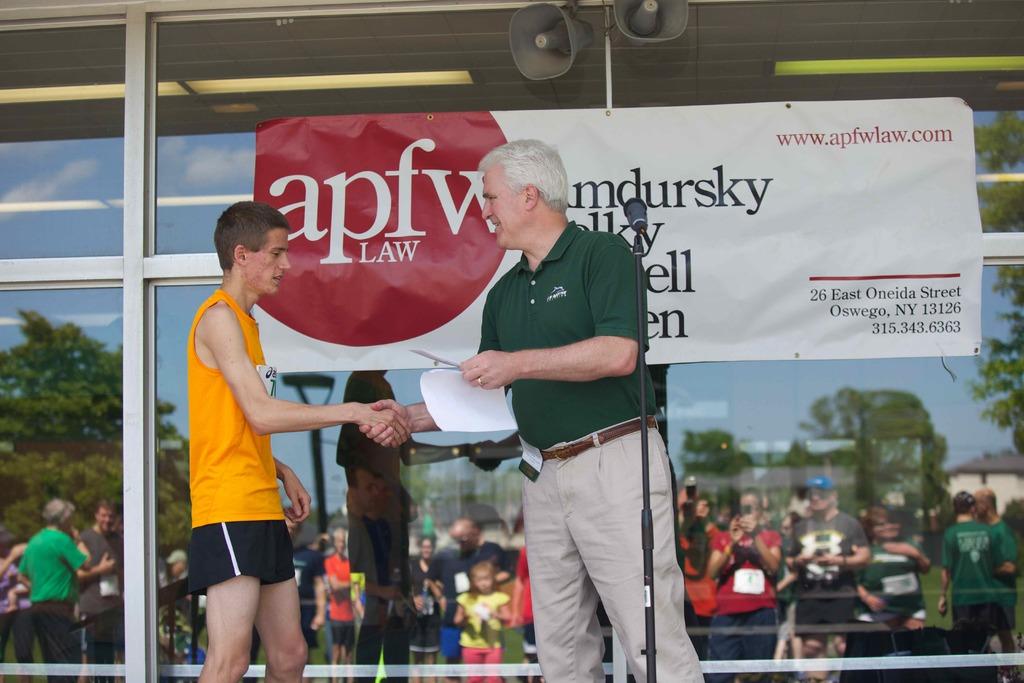What is the law company's website?
Offer a terse response. Www.apfwlaw.com. 